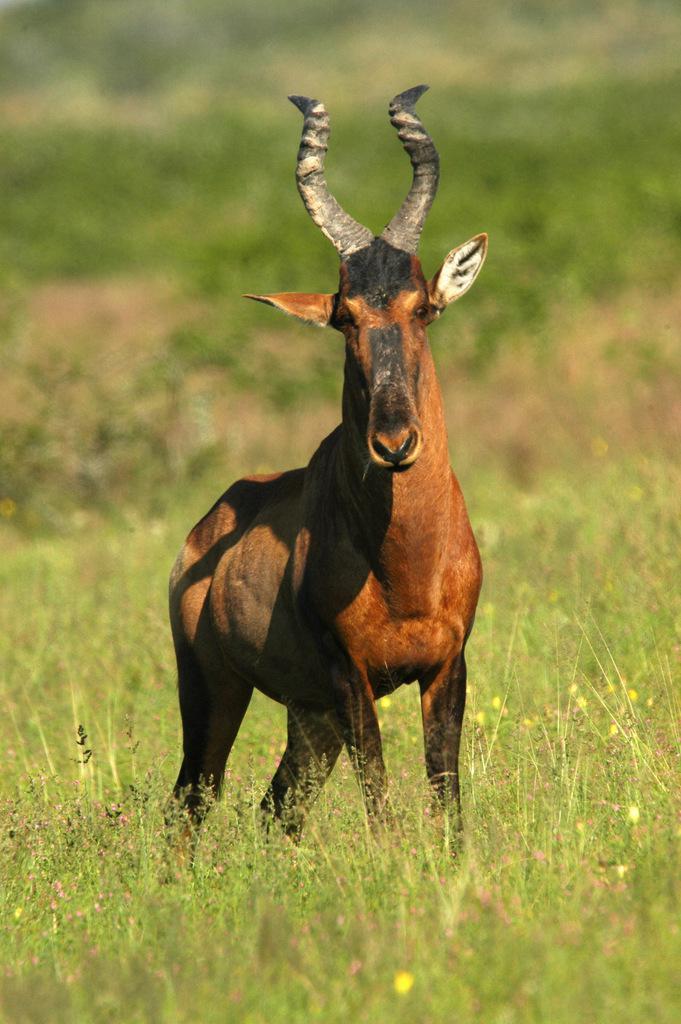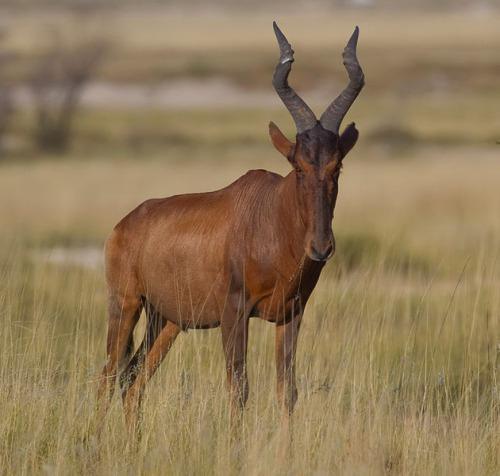The first image is the image on the left, the second image is the image on the right. For the images shown, is this caption "There are three gazelle-type creatures standing." true? Answer yes or no. No. The first image is the image on the left, the second image is the image on the right. Analyze the images presented: Is the assertion "There are more animals in the image on the right than on the left." valid? Answer yes or no. No. The first image is the image on the left, the second image is the image on the right. Analyze the images presented: Is the assertion "The right image shows more than one antelope-type animal." valid? Answer yes or no. No. 